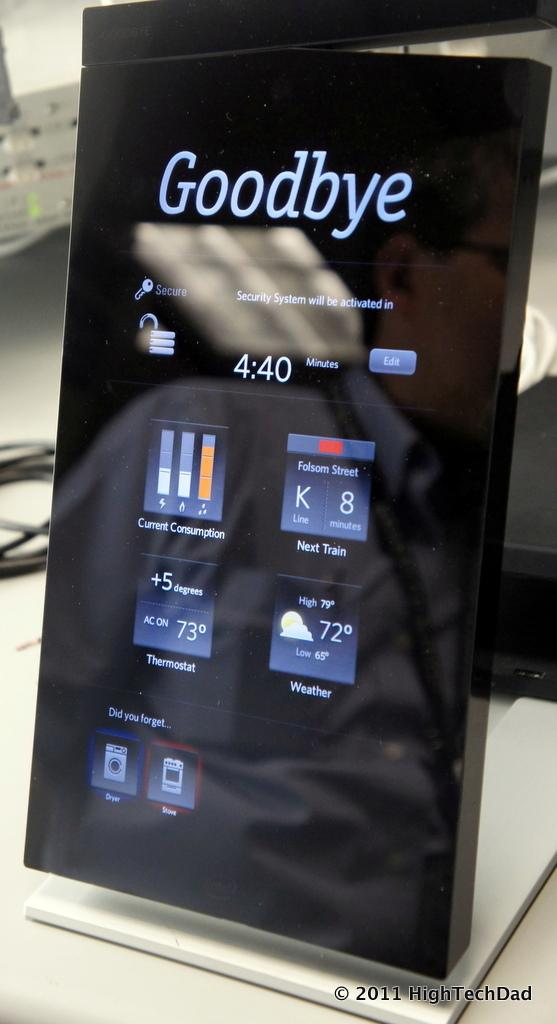<image>
Write a terse but informative summary of the picture. A digitial displaying showing statistics controls around the home such as a/c temperature and laundry settings. 